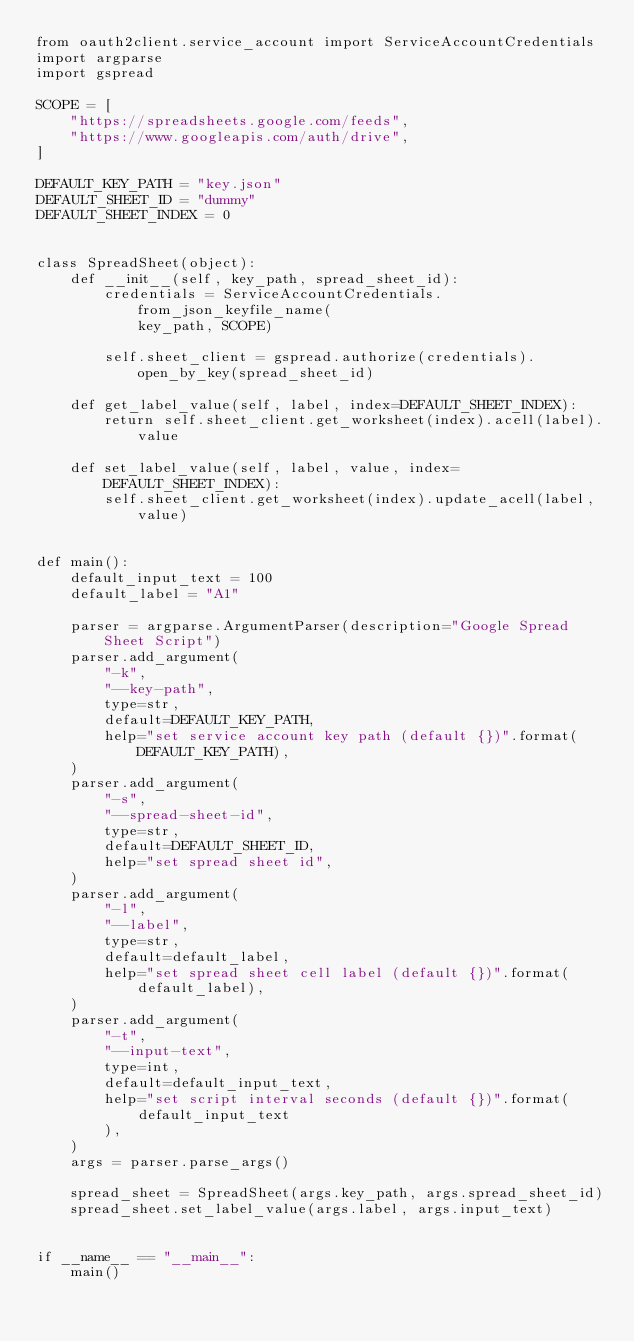<code> <loc_0><loc_0><loc_500><loc_500><_Python_>from oauth2client.service_account import ServiceAccountCredentials
import argparse
import gspread

SCOPE = [
    "https://spreadsheets.google.com/feeds",
    "https://www.googleapis.com/auth/drive",
]

DEFAULT_KEY_PATH = "key.json"
DEFAULT_SHEET_ID = "dummy"
DEFAULT_SHEET_INDEX = 0


class SpreadSheet(object):
    def __init__(self, key_path, spread_sheet_id):
        credentials = ServiceAccountCredentials.from_json_keyfile_name(
            key_path, SCOPE)

        self.sheet_client = gspread.authorize(credentials).open_by_key(spread_sheet_id)

    def get_label_value(self, label, index=DEFAULT_SHEET_INDEX):
        return self.sheet_client.get_worksheet(index).acell(label).value

    def set_label_value(self, label, value, index=DEFAULT_SHEET_INDEX):
        self.sheet_client.get_worksheet(index).update_acell(label, value)


def main():
    default_input_text = 100
    default_label = "A1"

    parser = argparse.ArgumentParser(description="Google Spread Sheet Script")
    parser.add_argument(
        "-k",
        "--key-path",
        type=str,
        default=DEFAULT_KEY_PATH,
        help="set service account key path (default {})".format(DEFAULT_KEY_PATH),
    )
    parser.add_argument(
        "-s",
        "--spread-sheet-id",
        type=str,
        default=DEFAULT_SHEET_ID,
        help="set spread sheet id",
    )
    parser.add_argument(
        "-l",
        "--label",
        type=str,
        default=default_label,
        help="set spread sheet cell label (default {})".format(default_label),
    )
    parser.add_argument(
        "-t",
        "--input-text",
        type=int,
        default=default_input_text,
        help="set script interval seconds (default {})".format(
            default_input_text
        ),
    )
    args = parser.parse_args()

    spread_sheet = SpreadSheet(args.key_path, args.spread_sheet_id)
    spread_sheet.set_label_value(args.label, args.input_text)


if __name__ == "__main__":
    main()
</code> 